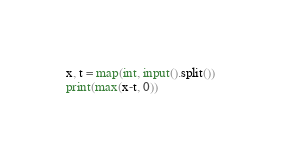Convert code to text. <code><loc_0><loc_0><loc_500><loc_500><_Python_>x, t = map(int, input().split())
print(max(x-t, 0))</code> 